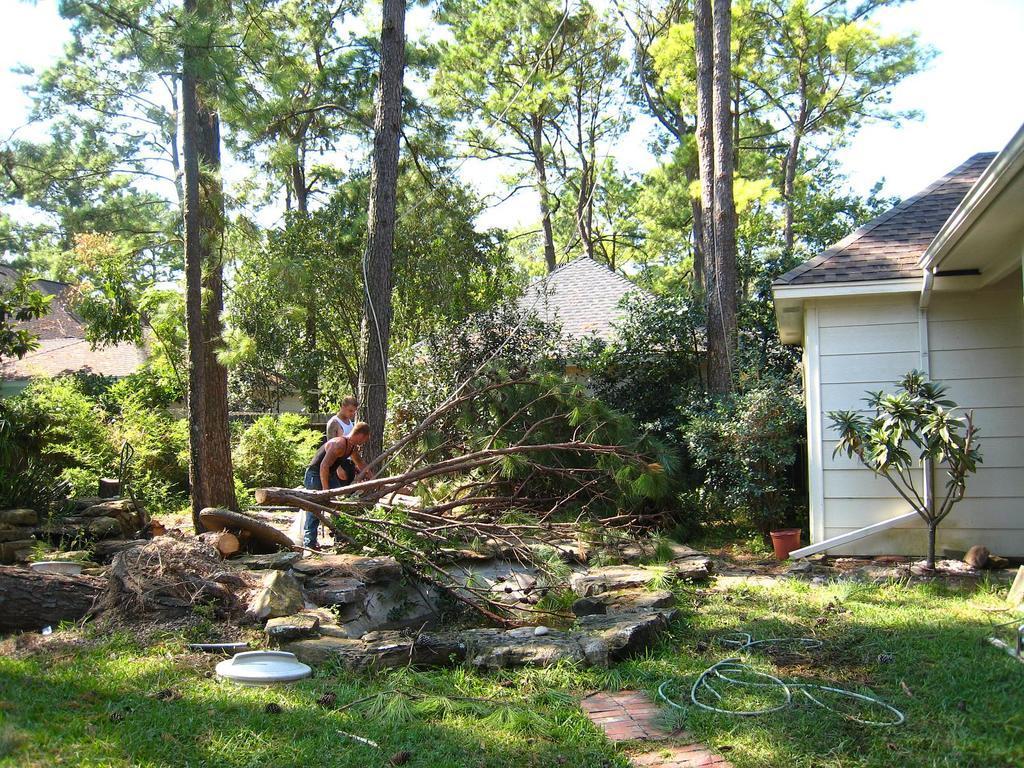How would you summarize this image in a sentence or two? This image consists of two men cutting trees. At the bottom, there is green grass. In the background, there are many trees. To the right, there is a house. 